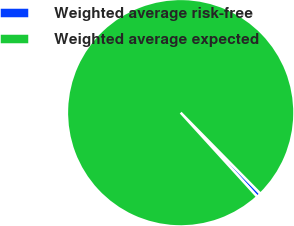Convert chart to OTSL. <chart><loc_0><loc_0><loc_500><loc_500><pie_chart><fcel>Weighted average risk-free<fcel>Weighted average expected<nl><fcel>0.62%<fcel>99.38%<nl></chart> 